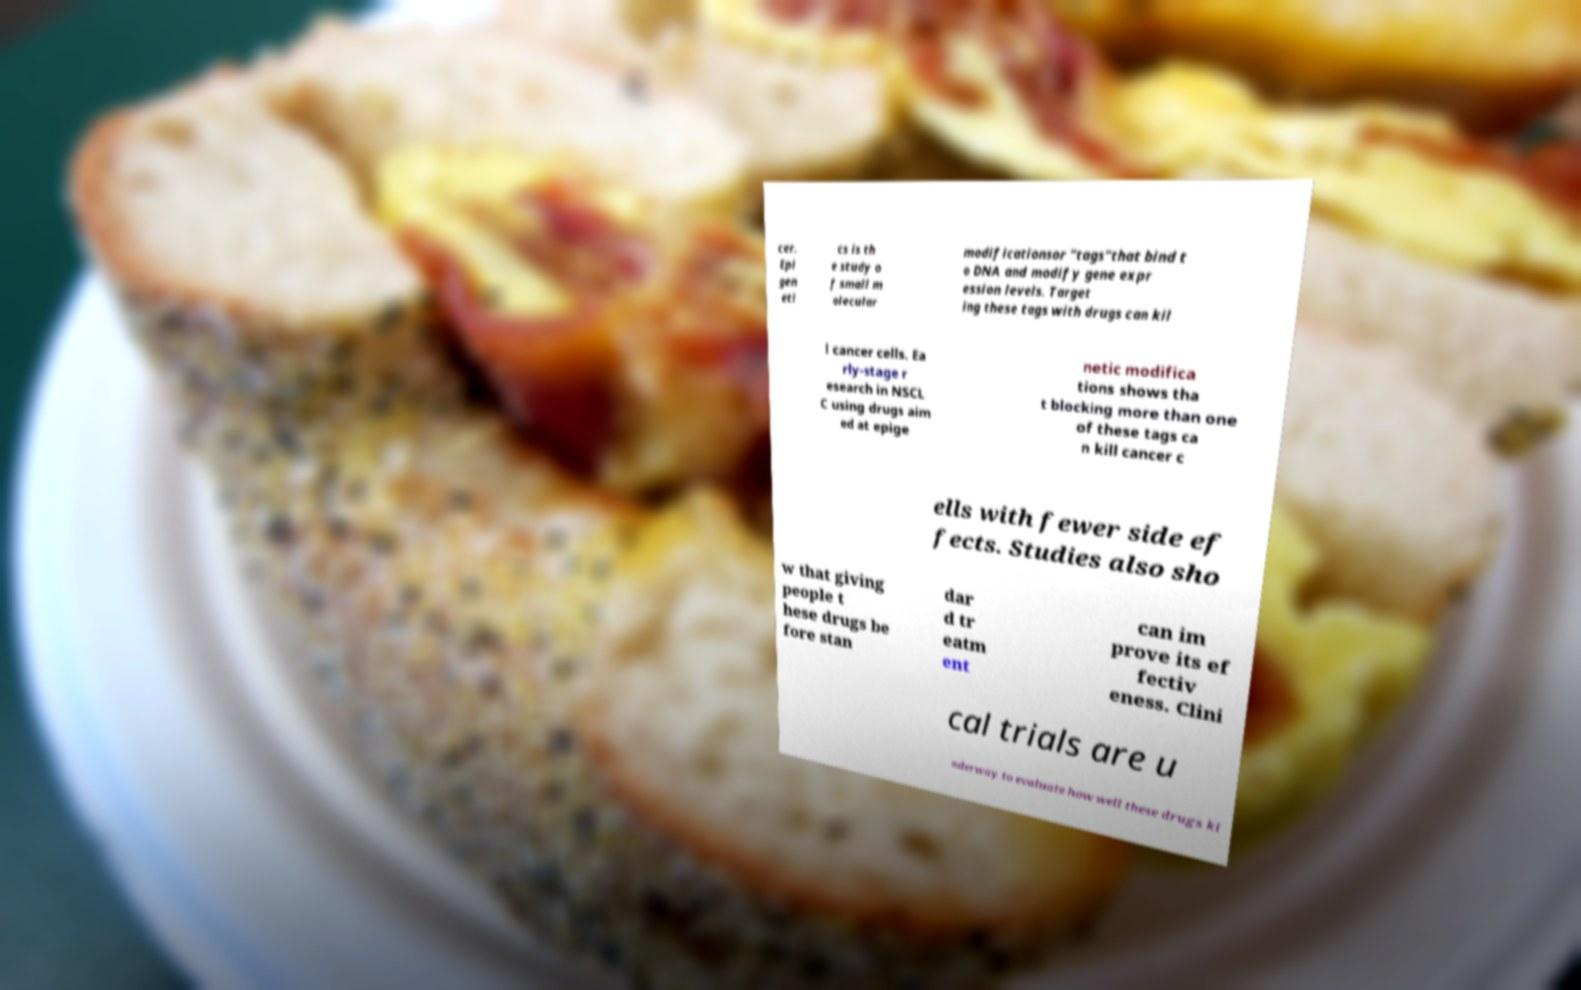What messages or text are displayed in this image? I need them in a readable, typed format. cer. Epi gen eti cs is th e study o f small m olecular modificationsor "tags"that bind t o DNA and modify gene expr ession levels. Target ing these tags with drugs can kil l cancer cells. Ea rly-stage r esearch in NSCL C using drugs aim ed at epige netic modifica tions shows tha t blocking more than one of these tags ca n kill cancer c ells with fewer side ef fects. Studies also sho w that giving people t hese drugs be fore stan dar d tr eatm ent can im prove its ef fectiv eness. Clini cal trials are u nderway to evaluate how well these drugs ki 